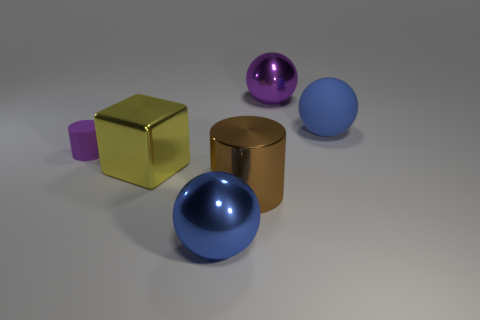What is the size of the other object that is the same color as the big rubber thing?
Offer a very short reply. Large. Are there any other things that have the same size as the purple matte thing?
Offer a very short reply. No. What number of big yellow things are the same shape as the large brown object?
Offer a very short reply. 0. What number of things are either rubber objects that are behind the matte cylinder or big blue shiny balls that are right of the block?
Your answer should be very brief. 2. What material is the big blue ball that is right of the big shiny ball behind the rubber thing on the right side of the purple sphere?
Your response must be concise. Rubber. There is a big metal ball that is to the right of the large blue metallic object; does it have the same color as the tiny object?
Your response must be concise. Yes. What material is the thing that is both behind the large blue metallic object and in front of the big cube?
Your response must be concise. Metal. Is there a metal cylinder of the same size as the blue rubber ball?
Your response must be concise. Yes. How many small rubber objects are there?
Offer a terse response. 1. There is a yellow metallic thing; what number of blue objects are in front of it?
Make the answer very short. 1. 